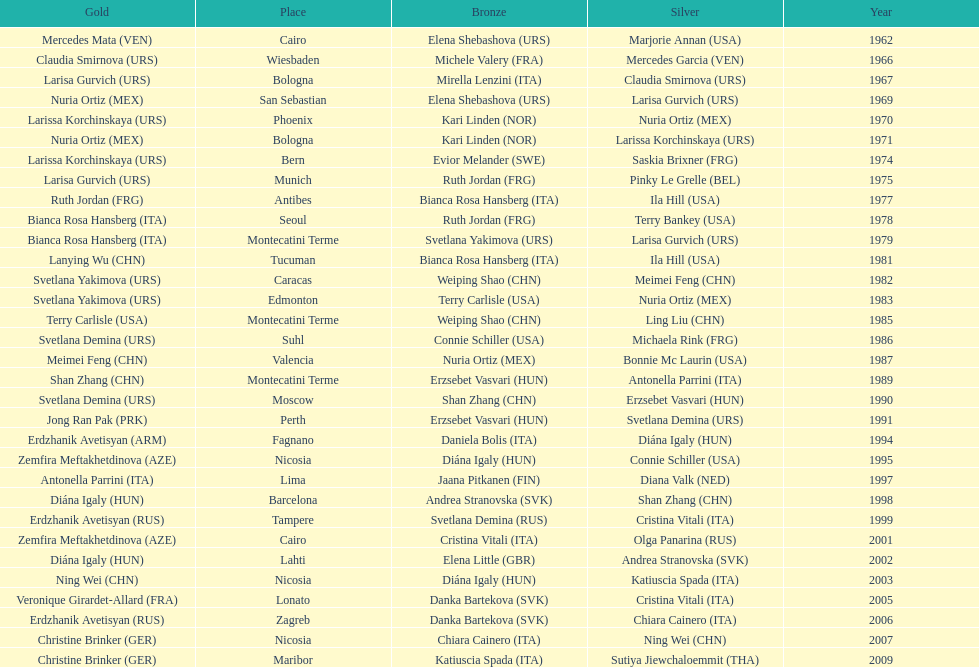Which country has won more gold medals: china or mexico? China. 